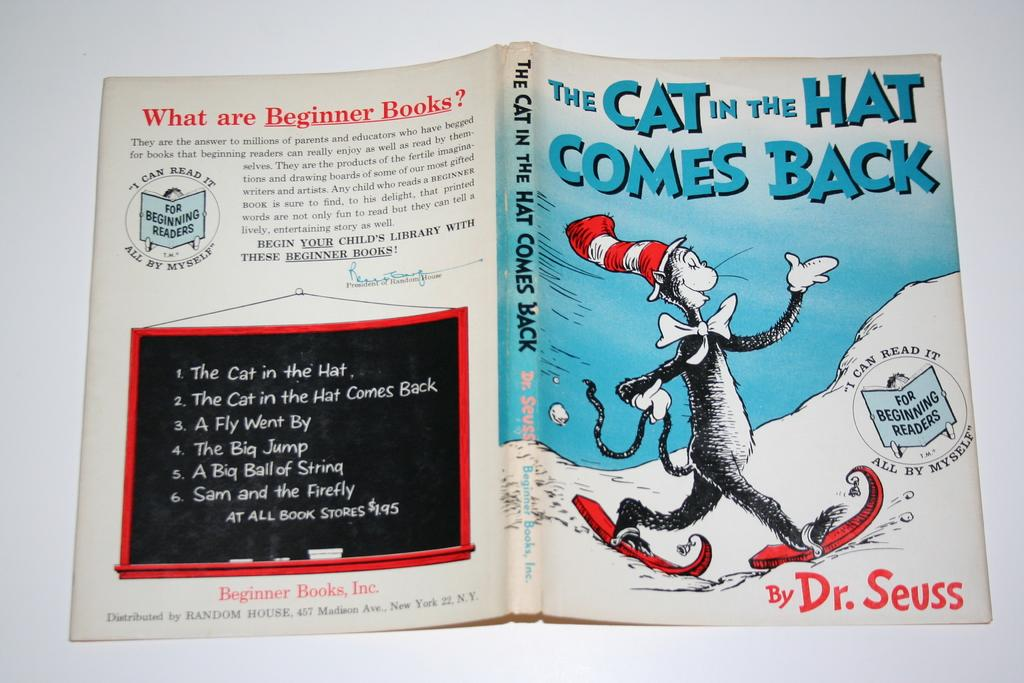<image>
Describe the image concisely. The Cat in The Hat book is written by Dr. Seuss. 